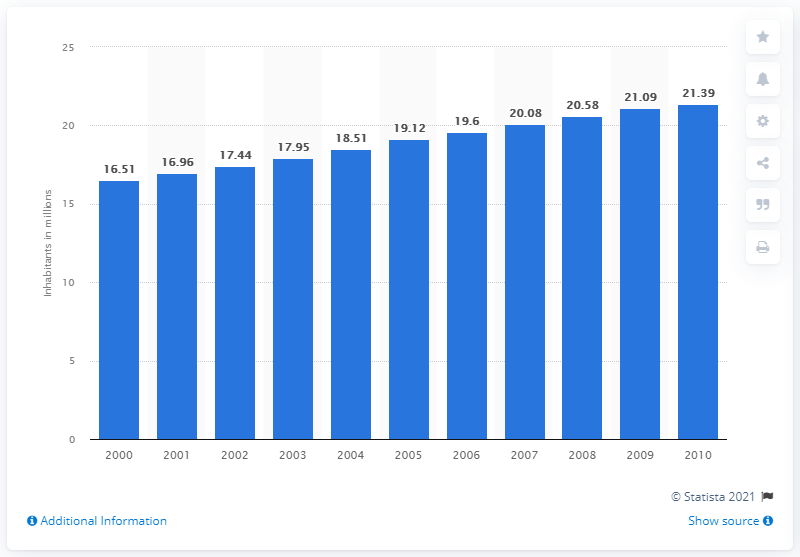Give some essential details in this illustration. In 2010, the population of Syria was 21.39 million. 